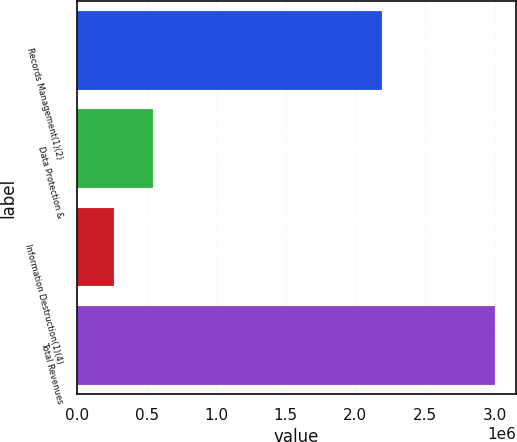Convert chart. <chart><loc_0><loc_0><loc_500><loc_500><bar_chart><fcel>Records Management(1)(2)<fcel>Data Protection &<fcel>Information Destruction(1)(4)<fcel>Total Revenues<nl><fcel>2.1936e+06<fcel>543426<fcel>268227<fcel>3.00526e+06<nl></chart> 